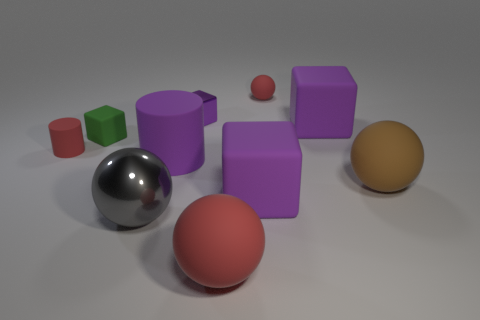How many balls are either big yellow objects or big things?
Keep it short and to the point. 3. Is the color of the big metal sphere the same as the large rubber cylinder?
Offer a very short reply. No. Is the number of tiny red matte cylinders that are right of the large red object the same as the number of matte cylinders on the right side of the green rubber thing?
Offer a very short reply. No. What color is the small matte block?
Offer a terse response. Green. How many things are large balls right of the big purple matte cylinder or large purple shiny objects?
Give a very brief answer. 2. Is the size of the shiny thing behind the green rubber cube the same as the purple matte block behind the tiny red cylinder?
Provide a succinct answer. No. Are there any other things that are made of the same material as the large red sphere?
Your response must be concise. Yes. How many objects are either things that are behind the big metal sphere or tiny red objects in front of the small green thing?
Offer a very short reply. 8. Do the tiny purple cube and the red sphere behind the large metal sphere have the same material?
Give a very brief answer. No. What is the shape of the red object that is behind the big gray metal thing and to the right of the large metal object?
Keep it short and to the point. Sphere. 